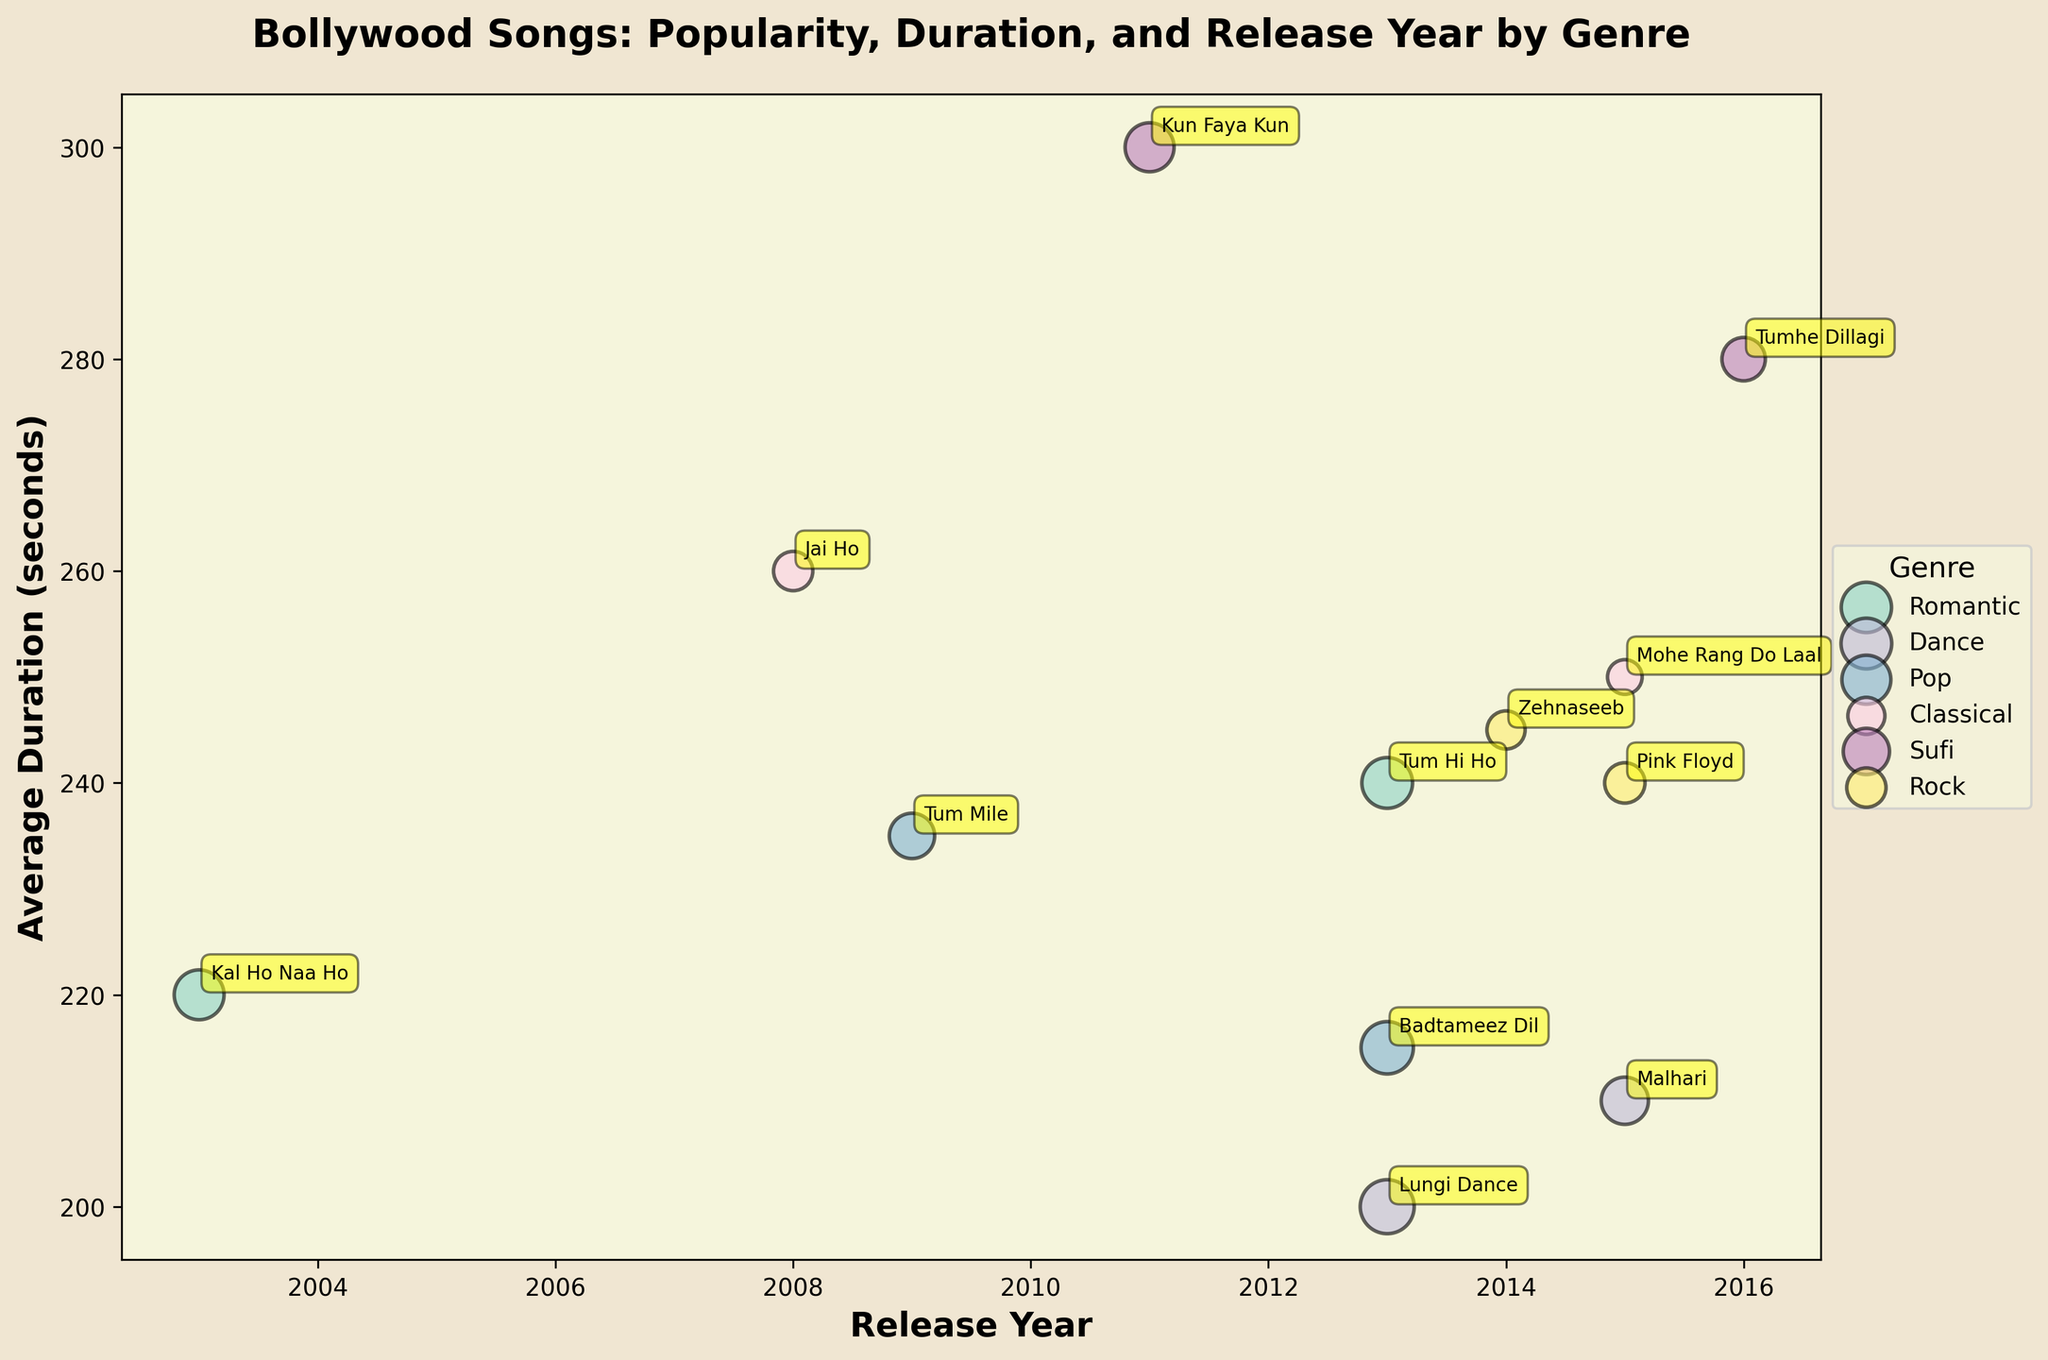What is the title of the plot? The title of the plot is displayed at the top center of the figure. It reads "Bollywood Songs: Popularity, Duration, and Release Year by Genre".
Answer: Bollywood Songs: Popularity, Duration, and Release Year by Genre Which genre has the largest bubble? By looking at the size of the bubbles, the genre with the largest bubble is Dance for the song "Lungi Dance" by Honey Singh.
Answer: Dance How many genres are depicted in the bubble chart? Each unique color represents a different genre. By counting the distinct colors and matching them to the legend, there are five genres depicted: Romantic, Dance, Pop, Classical, Sufi, and Rock.
Answer: Six Which year had the highest average duration song? We need to look at the y-axis values and find the highest y-value and its corresponding x-axis value. The highest average duration is around 2011 for the song "Kun Faya Kun" in the Sufi genre.
Answer: 2011 What is the average duration of "Malhari" (Dance genre)? Find the bubble corresponding to "Malhari" in the Dance genre. Its position along the y-axis indicates the average duration which is around 210 seconds.
Answer: 210 seconds Which genre was most popular in terms of number of streams in 2013? Look for the largest bubbles within the 2013 release year along the x-axis. The Dance genre has the largest bubble representing "Lungi Dance" with 170 million streams, making it the most popular genre in 2013.
Answer: Dance Compare the average duration of "Tum Hi Ho" and "Badtameez Dil". Which one is longer? Find the bubbles for "Tum Hi Ho" and "Badtameez Dil". "Tum Hi Ho" has an average duration of 240 seconds, while "Badtameez Dil" has 215 seconds. Hence, "Tum Hi Ho" has a longer duration.
Answer: Tum Hi Ho Which artist has multiple songs in different genres, and what are those genres? Look for repeated artist names across different colored bubbles representing different genres. Arijit Singh appears in both the Romantic genre ("Tum Hi Ho") and Rock genre ("Pink Floyd").
Answer: Arijit Singh, Romantic and Rock Which Sufi song has the highest number of streams and what is its duration? Focus on the bubbles in the Sufi genre and compare their sizes. "Kun Faya Kun" by A.R. Rahman has the highest streams with 140 million and a duration of 300 seconds.
Answer: Kun Faya Kun, 300 seconds 